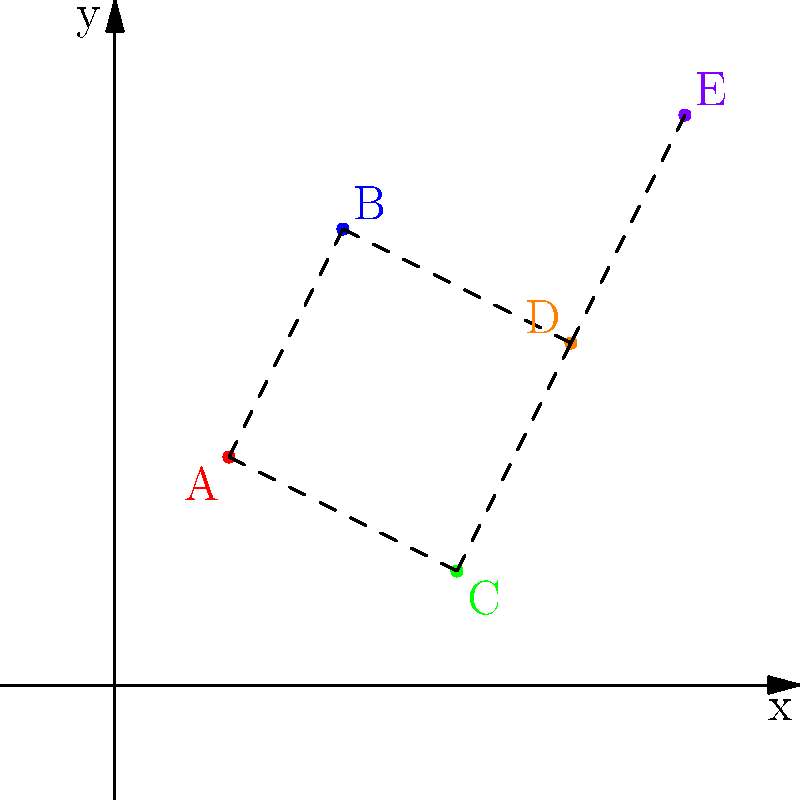In a social network analysis, five individuals (A, B, C, D, and E) are plotted on a 2D coordinate system based on their influence (x-axis) and leadership potential (y-axis). Given the connections shown in the graph, which individual is most likely to be a central connector in this social network, and why? To determine the central connector in this social network, we need to analyze the connections and positions of each individual:

1. Count the connections for each individual:
   A: 2 connections (B and C)
   B: 2 connections (A and D)
   C: 2 connections (A and D)
   D: 3 connections (B, C, and E)
   E: 1 connection (D)

2. Analyze the positions:
   A: (1,2) - Low influence, moderate leadership
   B: (2,4) - Moderate influence, high leadership
   C: (3,1) - Moderate influence, low leadership
   D: (4,3) - High influence, moderate-high leadership
   E: (5,5) - Highest influence and leadership

3. Consider both connections and position:
   D has the most connections (3) and is positioned towards the higher end of both influence and leadership scales.

4. Evaluate the central position:
   D is located in the middle of the network, connecting the left side (A, B, C) with the right side (E).

Based on these factors, D is most likely to be the central connector in this social network. D has the highest number of connections, a favorable position in terms of influence and leadership, and serves as a bridge between different parts of the network.
Answer: D 